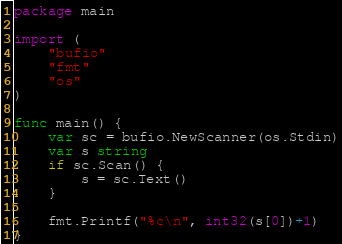Convert code to text. <code><loc_0><loc_0><loc_500><loc_500><_Go_>package main

import (
	"bufio"
	"fmt"
	"os"
)

func main() {
	var sc = bufio.NewScanner(os.Stdin)
	var s string
	if sc.Scan() {
		s = sc.Text()
	}

	fmt.Printf("%c\n", int32(s[0])+1)
}
</code> 